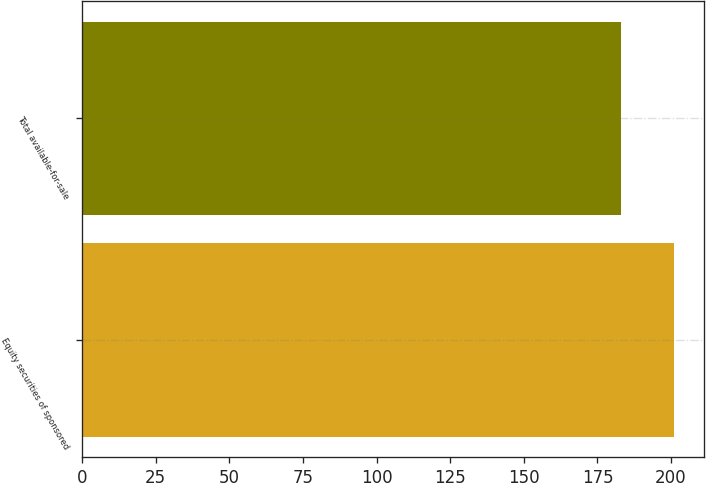Convert chart. <chart><loc_0><loc_0><loc_500><loc_500><bar_chart><fcel>Equity securities of sponsored<fcel>Total available-for-sale<nl><fcel>201<fcel>183<nl></chart> 